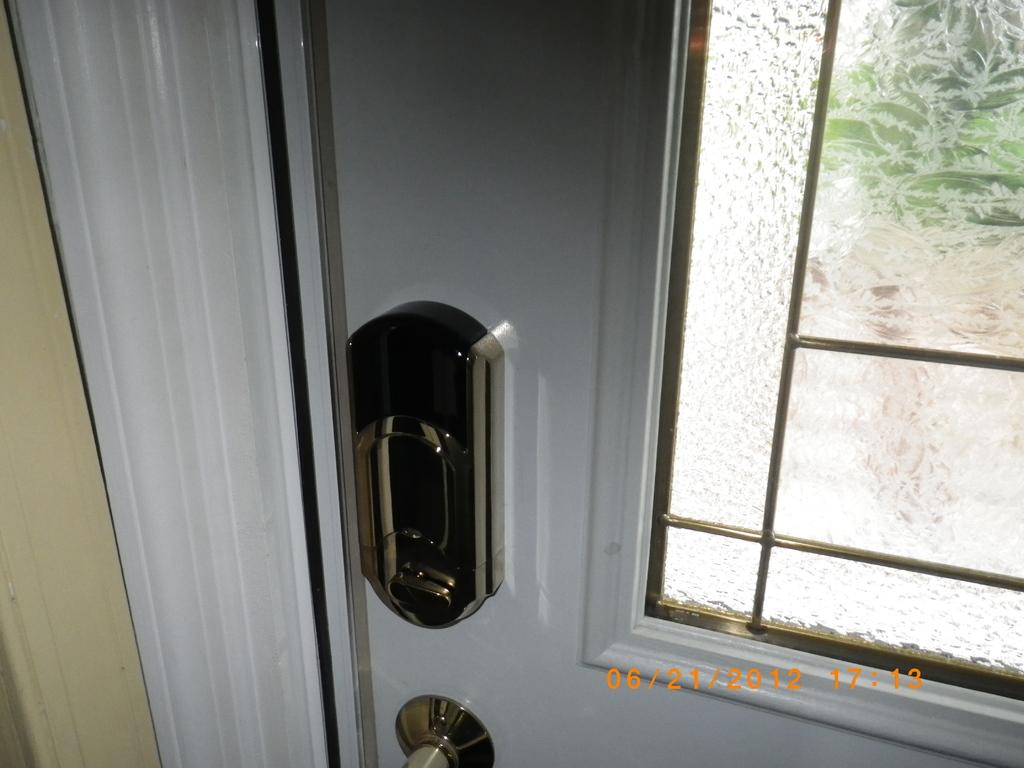What type of structure can be seen in the image? There is a door in the image. What material is present in the image? There is glass in the image. Is there any additional information provided in the image? Yes, there is a timestamp at the bottom of the image. How many matches are visible in the image? There are no matches present in the image. Is there a visitor in the image? The image does not depict a visitor; it only shows a door, glass, and a timestamp. 